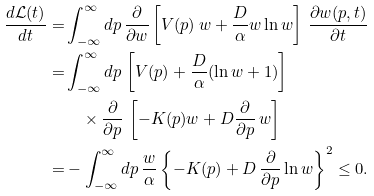<formula> <loc_0><loc_0><loc_500><loc_500>\frac { d { \mathcal { L } } ( t ) } { d t } = & \int _ { - \infty } ^ { \infty } d p \, \frac { \partial } { \partial w } \left [ V ( p ) \, w + \frac { D } { \alpha } w \ln w \right ] \, \frac { \partial w ( p , t ) } { \partial t } \\ = & \int _ { - \infty } ^ { \infty } d p \, \left [ V ( p ) + \frac { D } { \alpha } ( \ln w + 1 ) \right ] \\ & \quad \times \frac { \partial } { \partial p } \, \left [ - K ( p ) w + D \frac { \partial } { \partial p } \, w \right ] \\ = & - \int _ { - \infty } ^ { \infty } d p \, \frac { w } { \alpha } \left \{ - K ( p ) + D \, \frac { \partial } { \partial p } \ln w \right \} ^ { 2 } \leq 0 .</formula> 